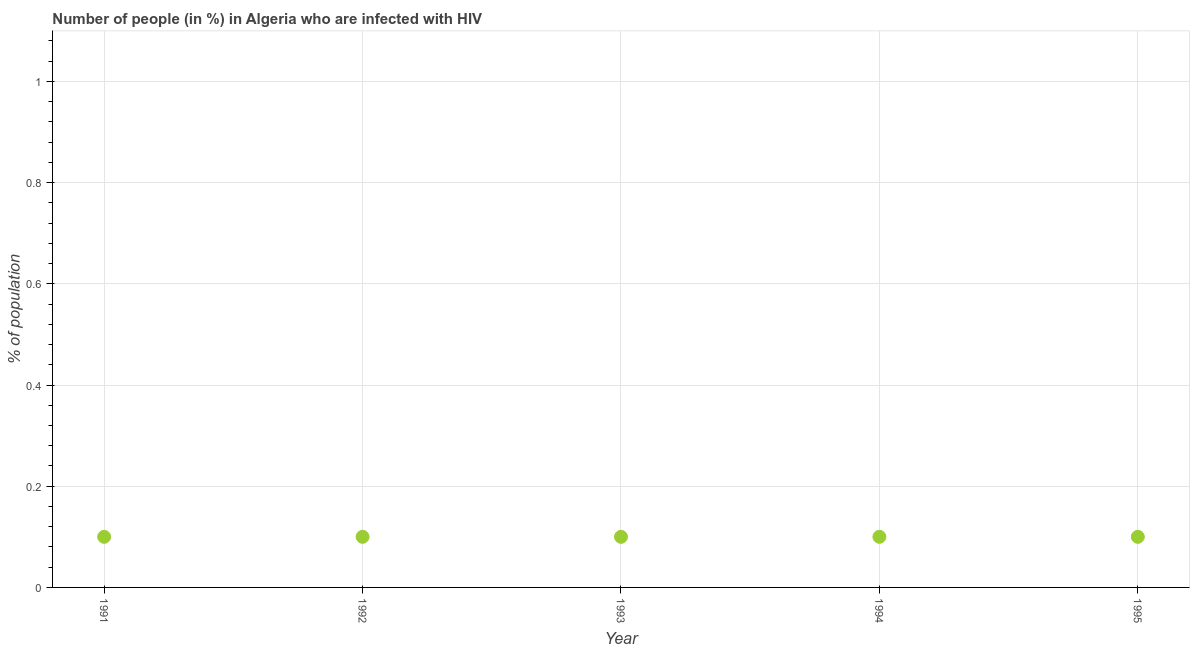What is the sum of the number of people infected with hiv?
Your response must be concise. 0.5. What is the average number of people infected with hiv per year?
Make the answer very short. 0.1. In how many years, is the number of people infected with hiv greater than 0.36 %?
Ensure brevity in your answer.  0. What is the ratio of the number of people infected with hiv in 1993 to that in 1994?
Your answer should be very brief. 1. Is the number of people infected with hiv in 1991 less than that in 1993?
Provide a succinct answer. No. What is the difference between the highest and the second highest number of people infected with hiv?
Make the answer very short. 0. What is the difference between two consecutive major ticks on the Y-axis?
Your response must be concise. 0.2. Does the graph contain grids?
Give a very brief answer. Yes. What is the title of the graph?
Provide a short and direct response. Number of people (in %) in Algeria who are infected with HIV. What is the label or title of the X-axis?
Offer a very short reply. Year. What is the label or title of the Y-axis?
Provide a succinct answer. % of population. What is the % of population in 1994?
Provide a short and direct response. 0.1. What is the difference between the % of population in 1992 and 1994?
Keep it short and to the point. 0. What is the difference between the % of population in 1992 and 1995?
Keep it short and to the point. 0. What is the difference between the % of population in 1993 and 1995?
Your answer should be very brief. 0. What is the difference between the % of population in 1994 and 1995?
Give a very brief answer. 0. What is the ratio of the % of population in 1991 to that in 1993?
Provide a short and direct response. 1. What is the ratio of the % of population in 1992 to that in 1993?
Ensure brevity in your answer.  1. What is the ratio of the % of population in 1993 to that in 1995?
Your answer should be compact. 1. What is the ratio of the % of population in 1994 to that in 1995?
Offer a very short reply. 1. 